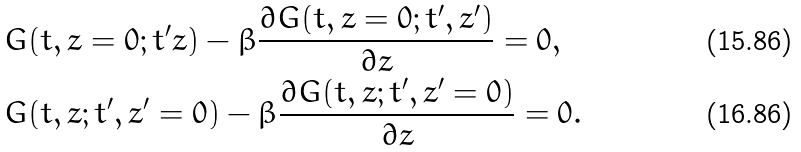Convert formula to latex. <formula><loc_0><loc_0><loc_500><loc_500>& G ( t , z = 0 ; t ^ { \prime } z ) - \beta \frac { \partial G ( t , z = 0 ; t ^ { \prime } , z ^ { \prime } ) } { \partial z } = 0 , \\ & G ( t , z ; t ^ { \prime } , z ^ { \prime } = 0 ) - \beta \frac { \partial G ( t , z ; t ^ { \prime } , z ^ { \prime } = 0 ) } { \partial z } = 0 .</formula> 